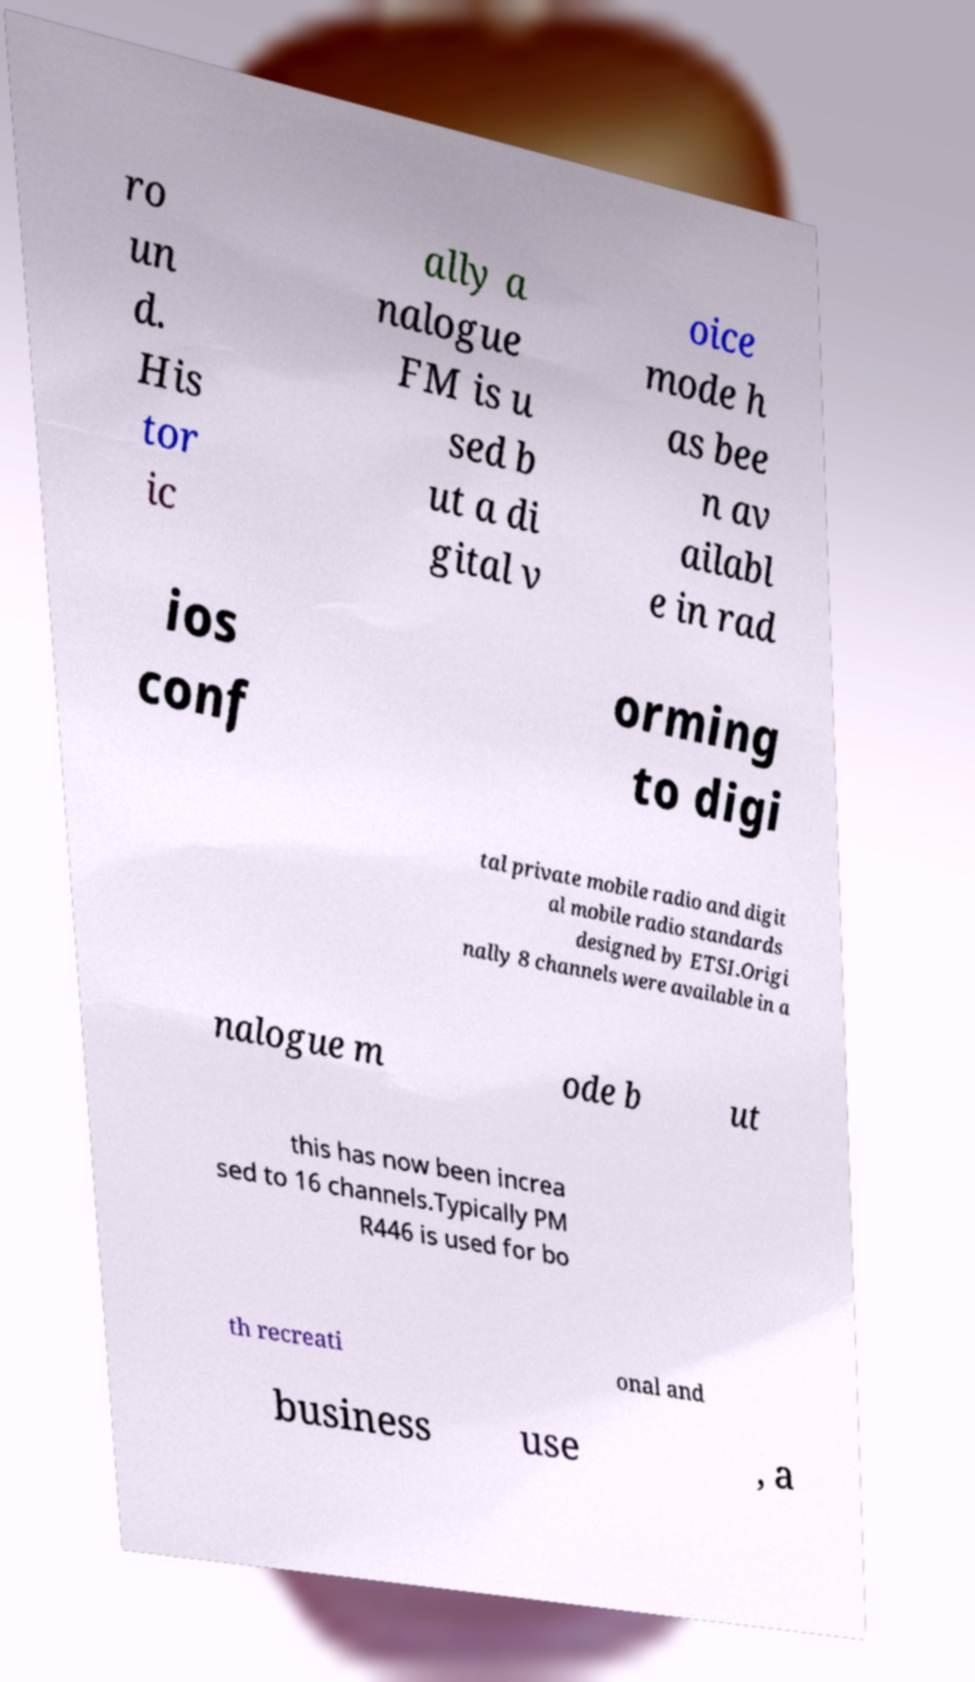Could you extract and type out the text from this image? ro un d. His tor ic ally a nalogue FM is u sed b ut a di gital v oice mode h as bee n av ailabl e in rad ios conf orming to digi tal private mobile radio and digit al mobile radio standards designed by ETSI.Origi nally 8 channels were available in a nalogue m ode b ut this has now been increa sed to 16 channels.Typically PM R446 is used for bo th recreati onal and business use , a 